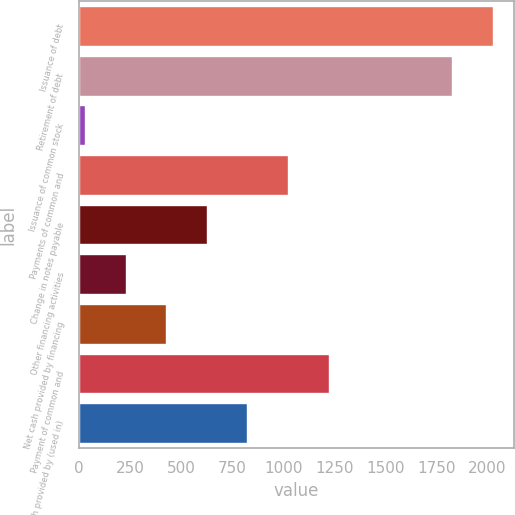Convert chart. <chart><loc_0><loc_0><loc_500><loc_500><bar_chart><fcel>Issuance of debt<fcel>Retirement of debt<fcel>Issuance of common stock<fcel>Payments of common and<fcel>Change in notes payable<fcel>Other financing activities<fcel>Net cash provided by financing<fcel>Payment of common and<fcel>Net cash provided by (used in)<nl><fcel>2027.7<fcel>1829<fcel>30<fcel>1023.5<fcel>626.1<fcel>228.7<fcel>427.4<fcel>1222.2<fcel>824.8<nl></chart> 